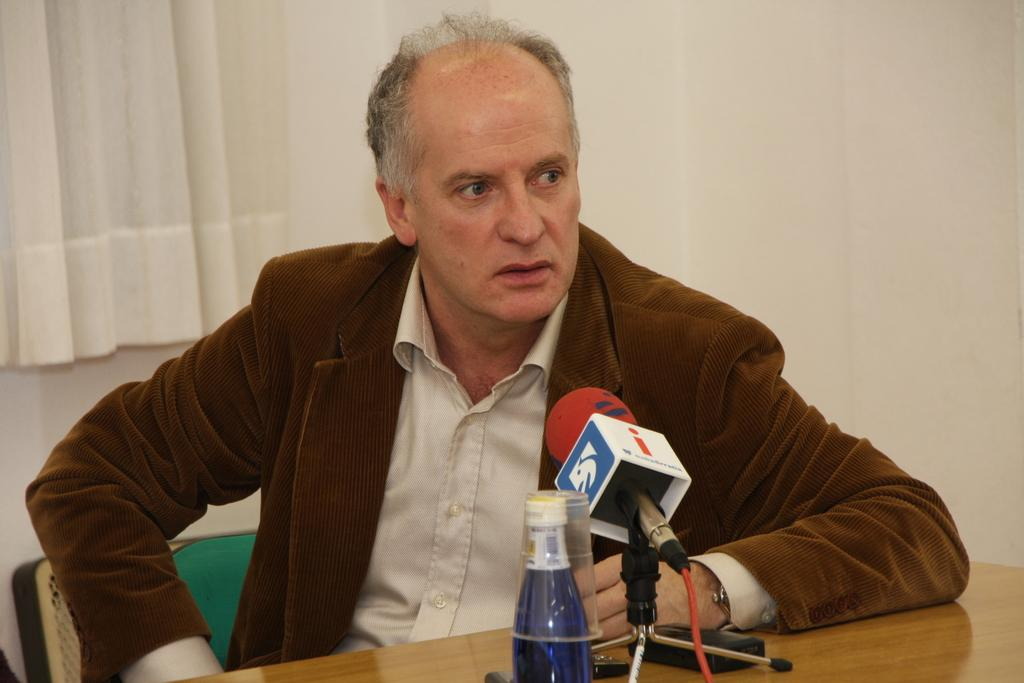Who is present in the image? There is a man in the image. What is located on the table in the image? There is a bottle and a microphone (mike) on the table. What can be seen in the background of the image? There is a wall and a curtain associated with the wall in the background. What type of paint is being sold at the market in the image? There is no market or paint present in the image. How much toothpaste is visible on the table in the image? There is no toothpaste present in the image. 